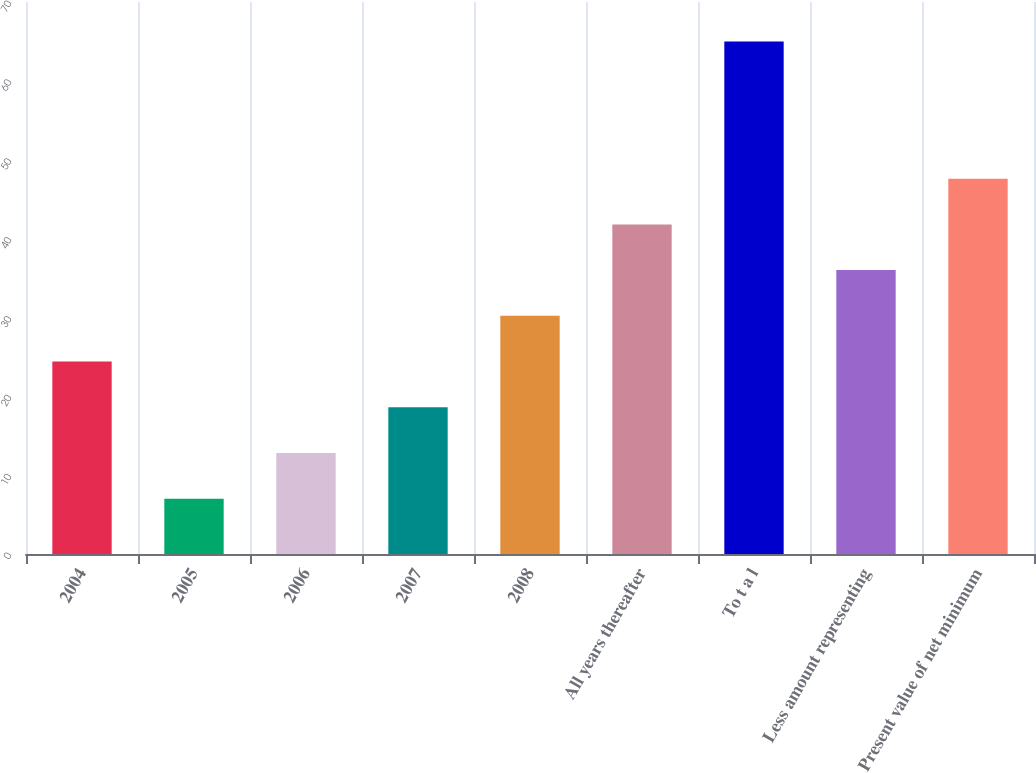Convert chart to OTSL. <chart><loc_0><loc_0><loc_500><loc_500><bar_chart><fcel>2004<fcel>2005<fcel>2006<fcel>2007<fcel>2008<fcel>All years thereafter<fcel>To t a l<fcel>Less amount representing<fcel>Present value of net minimum<nl><fcel>24.4<fcel>7<fcel>12.8<fcel>18.6<fcel>30.2<fcel>41.8<fcel>65<fcel>36<fcel>47.6<nl></chart> 